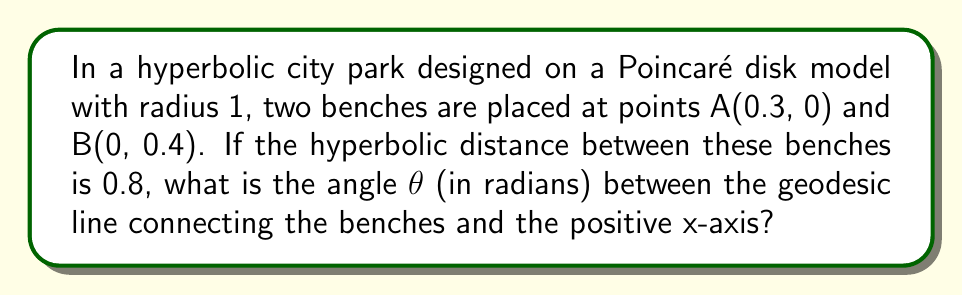Can you answer this question? Let's approach this step-by-step:

1) In the Poincaré disk model, the hyperbolic distance d between two points (x₁, y₁) and (x₂, y₂) is given by:

   $$d = 2\tanh^{-1}\left(\frac{\sqrt{(x_2-x_1)^2 + (y_2-y_1)^2}}{\sqrt{(1-x_1^2-y_1^2)(1-x_2^2-y_2^2) + (x_2-x_1)^2 + (y_2-y_1)^2}}\right)$$

2) We're given that A(0.3, 0) and B(0, 0.4), and the hyperbolic distance is 0.8. Let's substitute these into the formula:

   $$0.8 = 2\tanh^{-1}\left(\frac{\sqrt{(0-0.3)^2 + (0.4-0)^2}}{\sqrt{(1-0.3^2-0^2)(1-0^2-0.4^2) + (0-0.3)^2 + (0.4-0)^2}}\right)$$

3) Simplifying:

   $$0.8 = 2\tanh^{-1}\left(\frac{\sqrt{0.09 + 0.16}}{\sqrt{(1-0.09)(1-0.16) + 0.09 + 0.16}}\right) = 2\tanh^{-1}\left(\frac{0.5}{\sqrt{0.91 * 0.84 + 0.25}}\right)$$

4) Now, to find θ, we can use the formula for the angle between a geodesic and the x-axis in the Poincaré disk model:

   $$\tan\theta = \frac{y_2-y_1}{x_2-x_1} * \frac{1-x_1x_2-y_1y_2}{1+x_1x_2+y_1y_2}$$

5) Substituting our values:

   $$\tan\theta = \frac{0.4-0}{0-0.3} * \frac{1-0.3*0-0*0.4}{1+0.3*0+0*0.4} = \frac{-4}{3} * \frac{1}{1} = -\frac{4}{3}$$

6) Therefore:

   $$\theta = \tan^{-1}\left(-\frac{4}{3}\right)$$

7) Converting to radians:

   $$\theta ≈ -0.9273 \text{ radians}$$

8) Since we're asked for the angle between the geodesic and the positive x-axis, we take the absolute value:

   $$|\theta| ≈ 0.9273 \text{ radians}$$
Answer: 0.9273 radians 